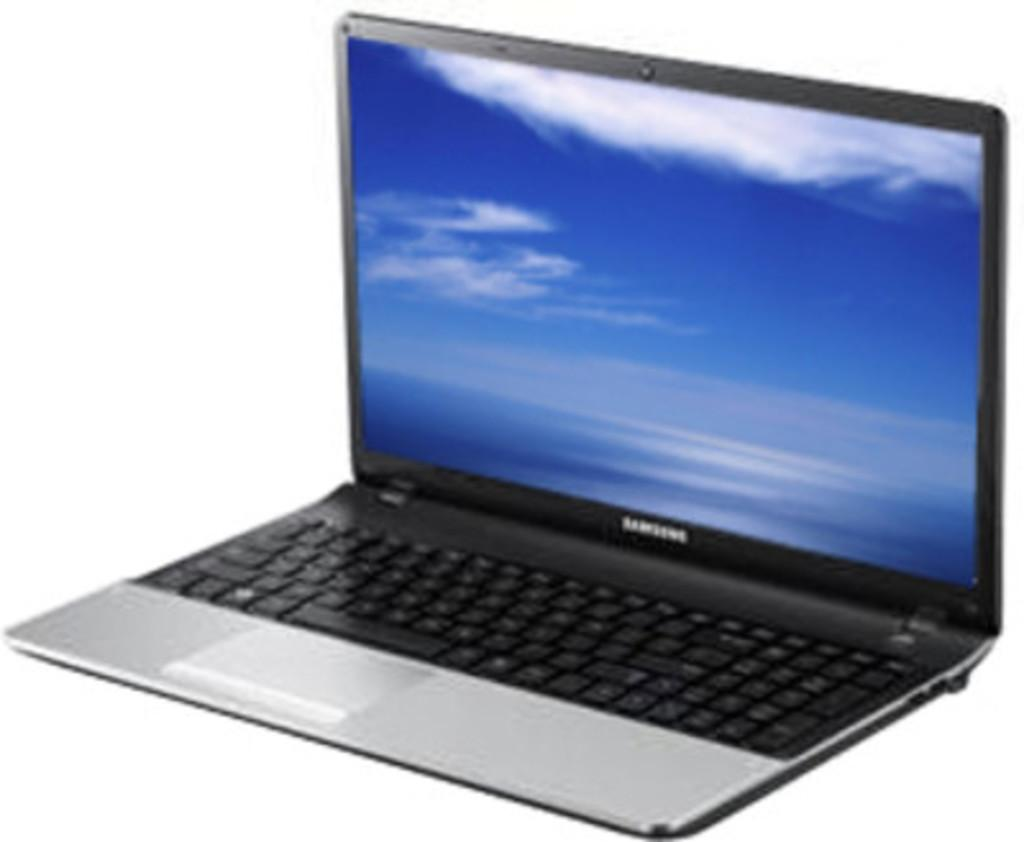<image>
Write a terse but informative summary of the picture. a Samsung lap top sitting on a white back ground 